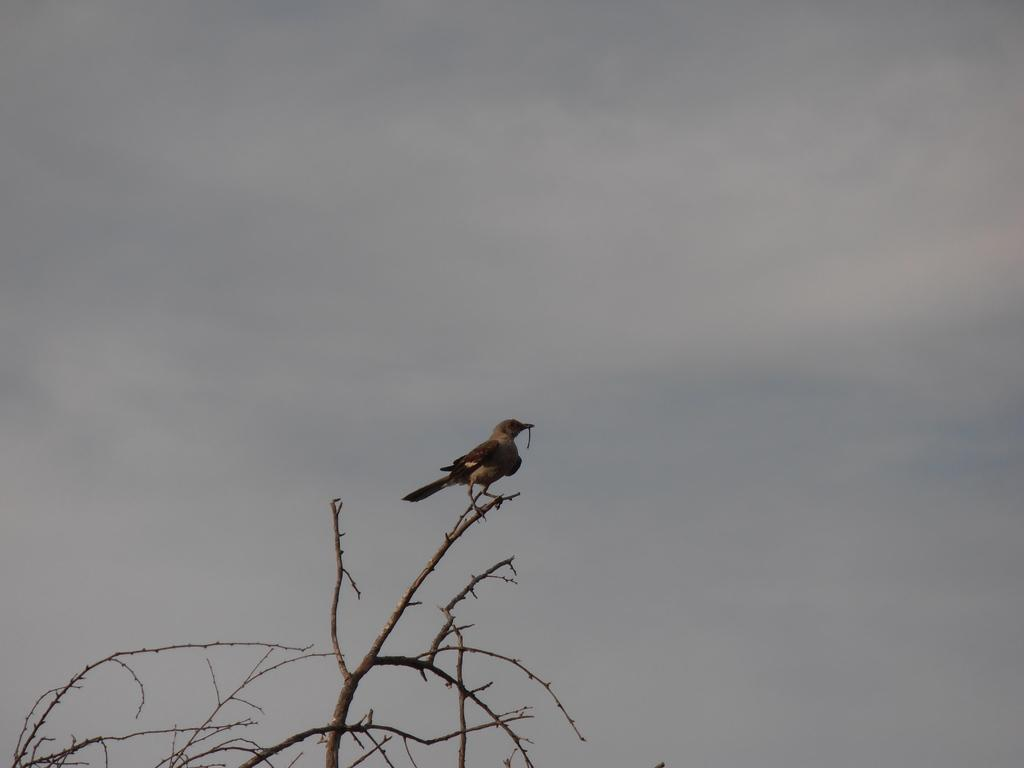What type of animal can be seen in the image? There is a bird in the image. Where is the bird located? The bird is on a branch of a tree. What can be seen in the background of the image? There is sky visible in the background of the image. How many ants are crawling on the bird in the image? There are no ants present in the image; it only features a bird on a tree branch. What type of punishment is the bird receiving in the image? There is no indication of punishment in the image; the bird is simply perched on a tree branch. 